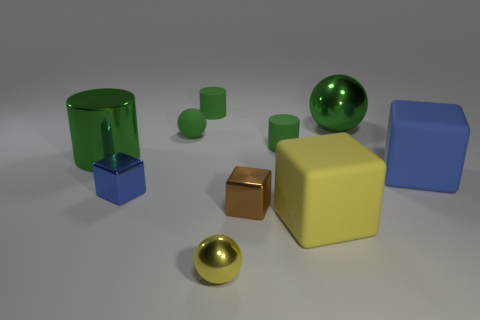What material is the big green object to the left of the large object that is behind the green metallic cylinder made of?
Provide a succinct answer. Metal. Do the shiny cylinder and the brown metal thing have the same size?
Offer a terse response. No. What number of large things are metallic balls or yellow rubber things?
Your answer should be compact. 2. How many balls are to the right of the tiny brown object?
Keep it short and to the point. 1. Are there more big green metal things on the left side of the tiny brown shiny cube than cyan objects?
Your answer should be compact. Yes. The large object that is the same material as the large sphere is what shape?
Ensure brevity in your answer.  Cylinder. The large matte thing that is to the right of the metallic thing that is behind the shiny cylinder is what color?
Your answer should be compact. Blue. Is the blue shiny object the same shape as the yellow rubber thing?
Offer a terse response. Yes. There is a large blue object that is the same shape as the tiny brown shiny object; what is its material?
Make the answer very short. Rubber. There is a metal ball that is in front of the large block that is on the right side of the large sphere; is there a sphere that is in front of it?
Ensure brevity in your answer.  No. 